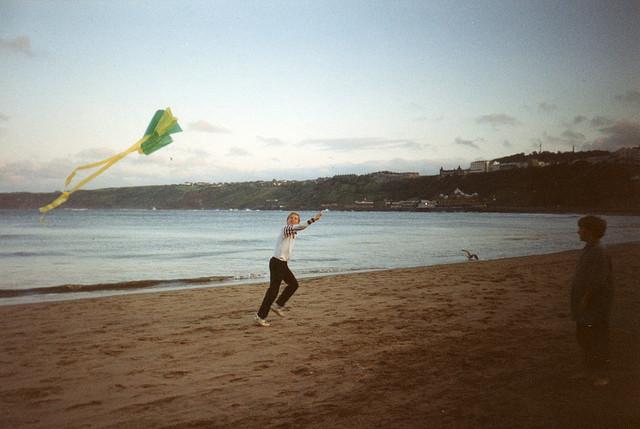Is it a sunny day?
Write a very short answer. No. Is it windy outside?
Give a very brief answer. Yes. Is there a seagull in this picture?
Answer briefly. Yes. What color is the boy's kite?
Give a very brief answer. Green. 